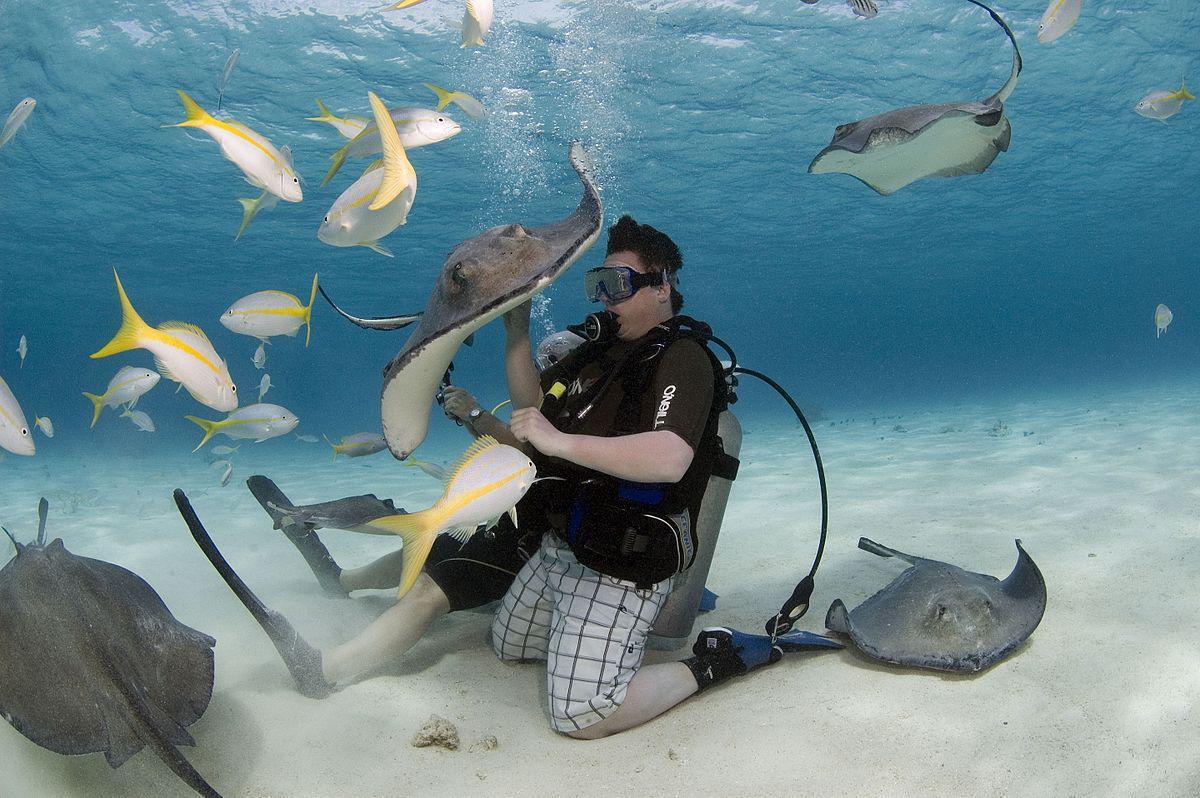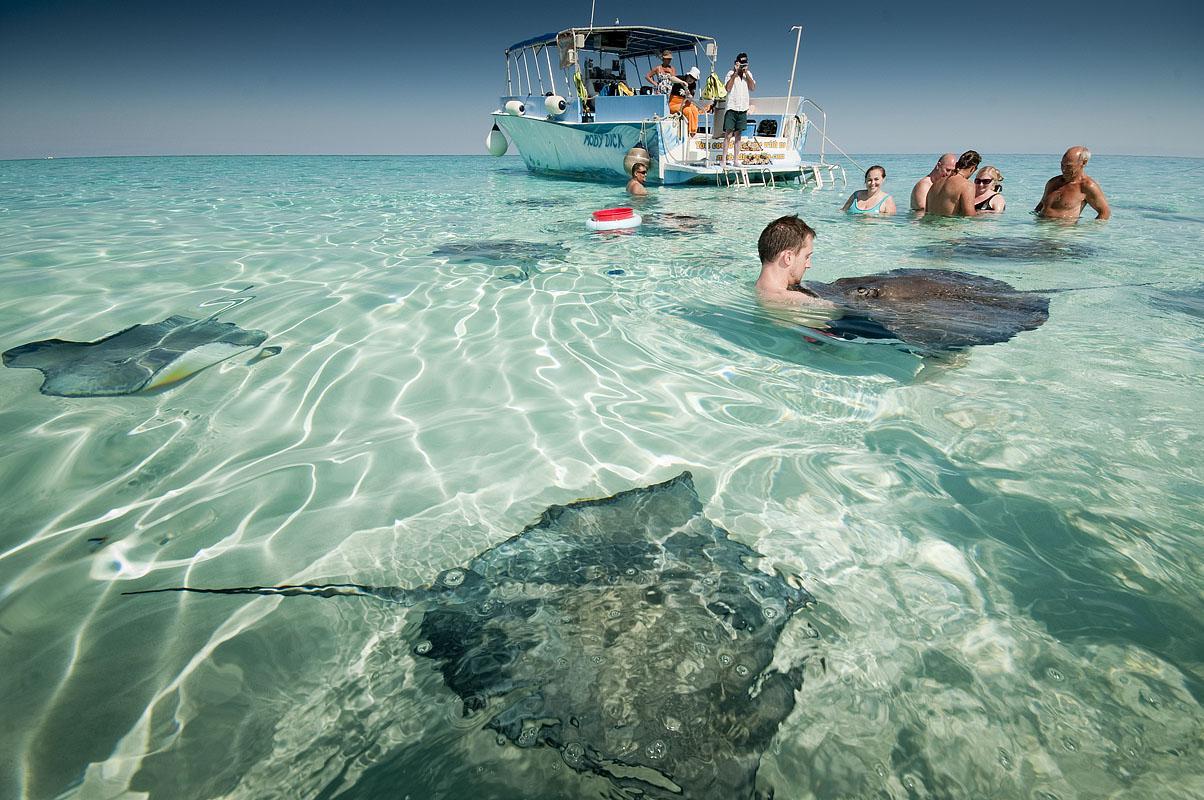The first image is the image on the left, the second image is the image on the right. For the images displayed, is the sentence "One image shows one person with goggles completely underwater near stingrays." factually correct? Answer yes or no. Yes. The first image is the image on the left, the second image is the image on the right. Examine the images to the left and right. Is the description "One or more large flat fish is interacting with one or more people." accurate? Answer yes or no. Yes. 